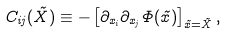Convert formula to latex. <formula><loc_0><loc_0><loc_500><loc_500>C _ { i j } ( \vec { X } ) \equiv - \left [ \partial _ { x _ { i } } \partial _ { x _ { j } } \Phi ( \vec { x } ) \right ] _ { \vec { x } = \vec { X } } ,</formula> 